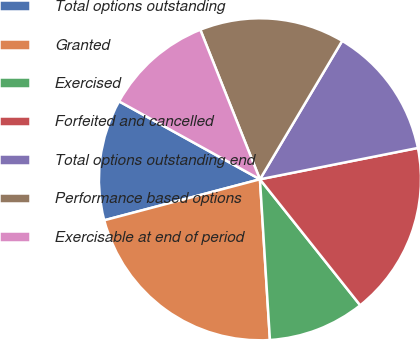<chart> <loc_0><loc_0><loc_500><loc_500><pie_chart><fcel>Total options outstanding<fcel>Granted<fcel>Exercised<fcel>Forfeited and cancelled<fcel>Total options outstanding end<fcel>Performance based options<fcel>Exercisable at end of period<nl><fcel>12.14%<fcel>21.89%<fcel>9.71%<fcel>17.42%<fcel>13.35%<fcel>14.57%<fcel>10.92%<nl></chart> 